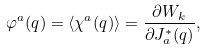<formula> <loc_0><loc_0><loc_500><loc_500>\varphi ^ { a } ( q ) = \langle \chi ^ { a } ( q ) \rangle = \frac { \partial W _ { k } } { \partial J _ { a } ^ { \ast } ( q ) } ,</formula> 